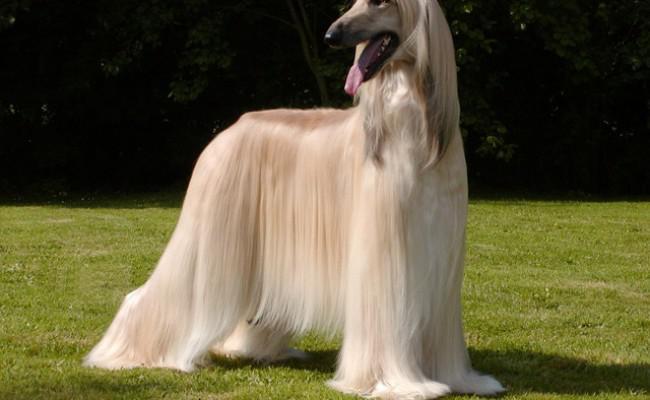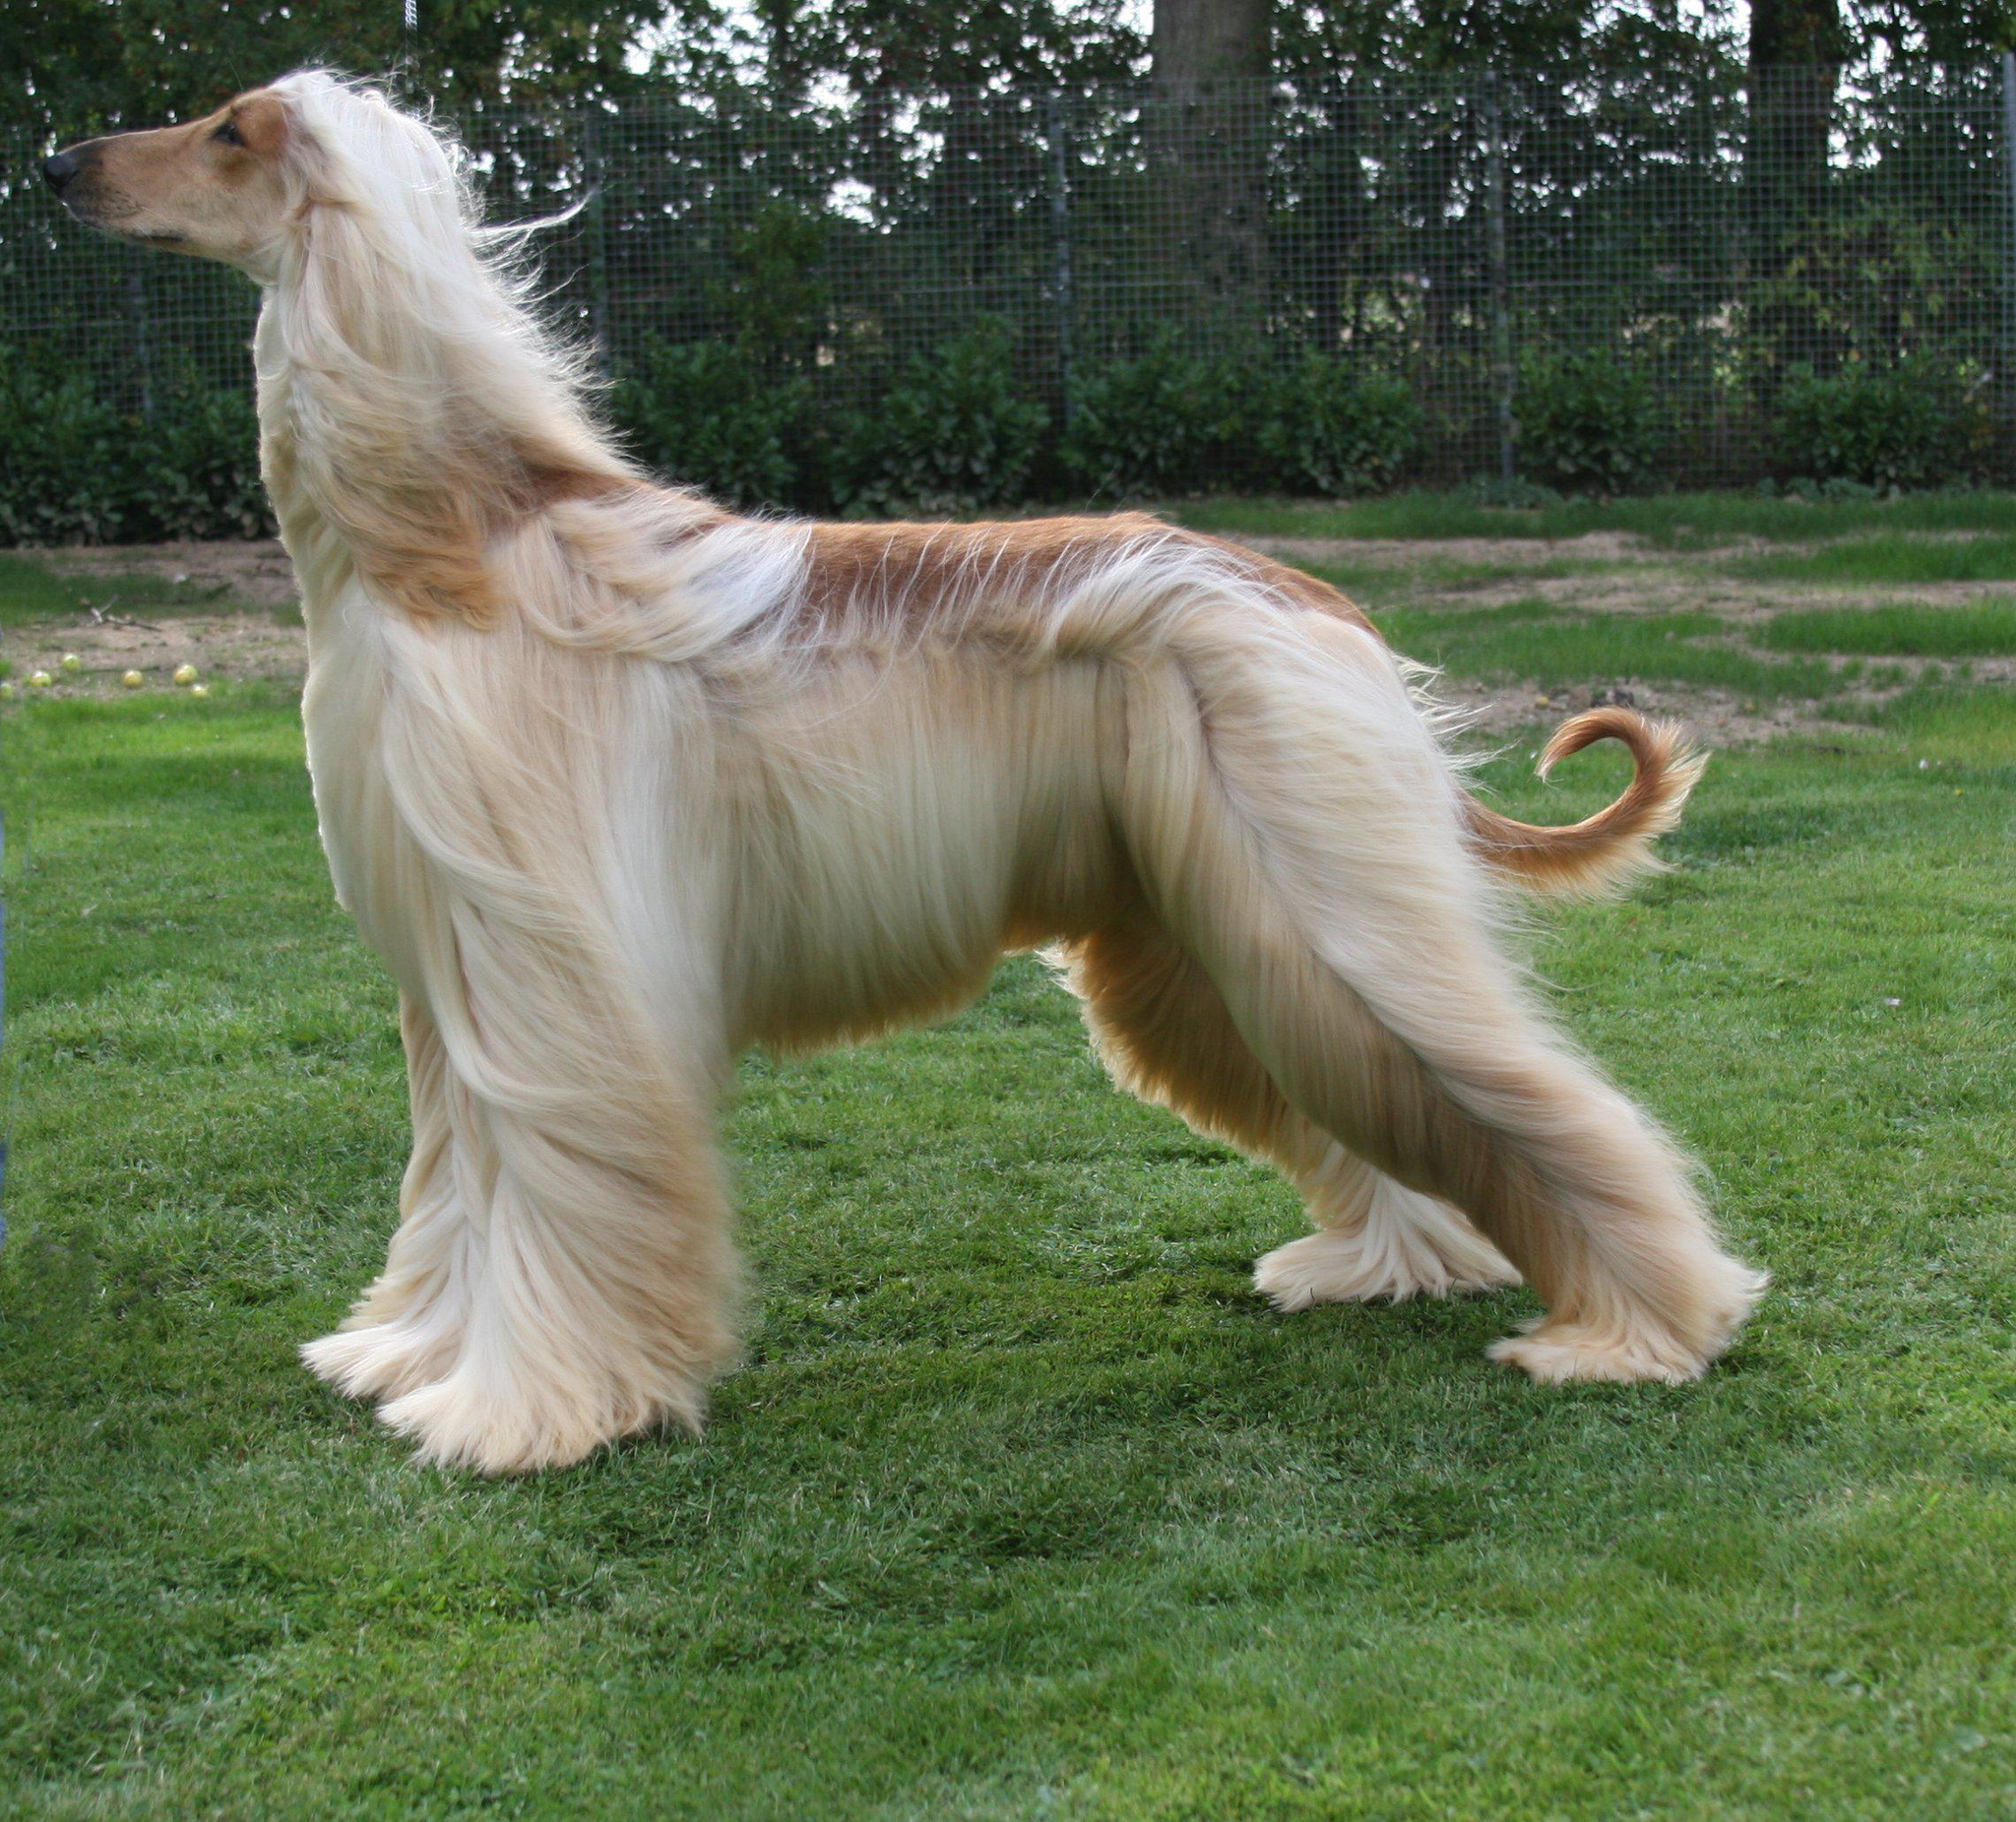The first image is the image on the left, the second image is the image on the right. Evaluate the accuracy of this statement regarding the images: "Both of the dogs are standing on the grass.". Is it true? Answer yes or no. Yes. 